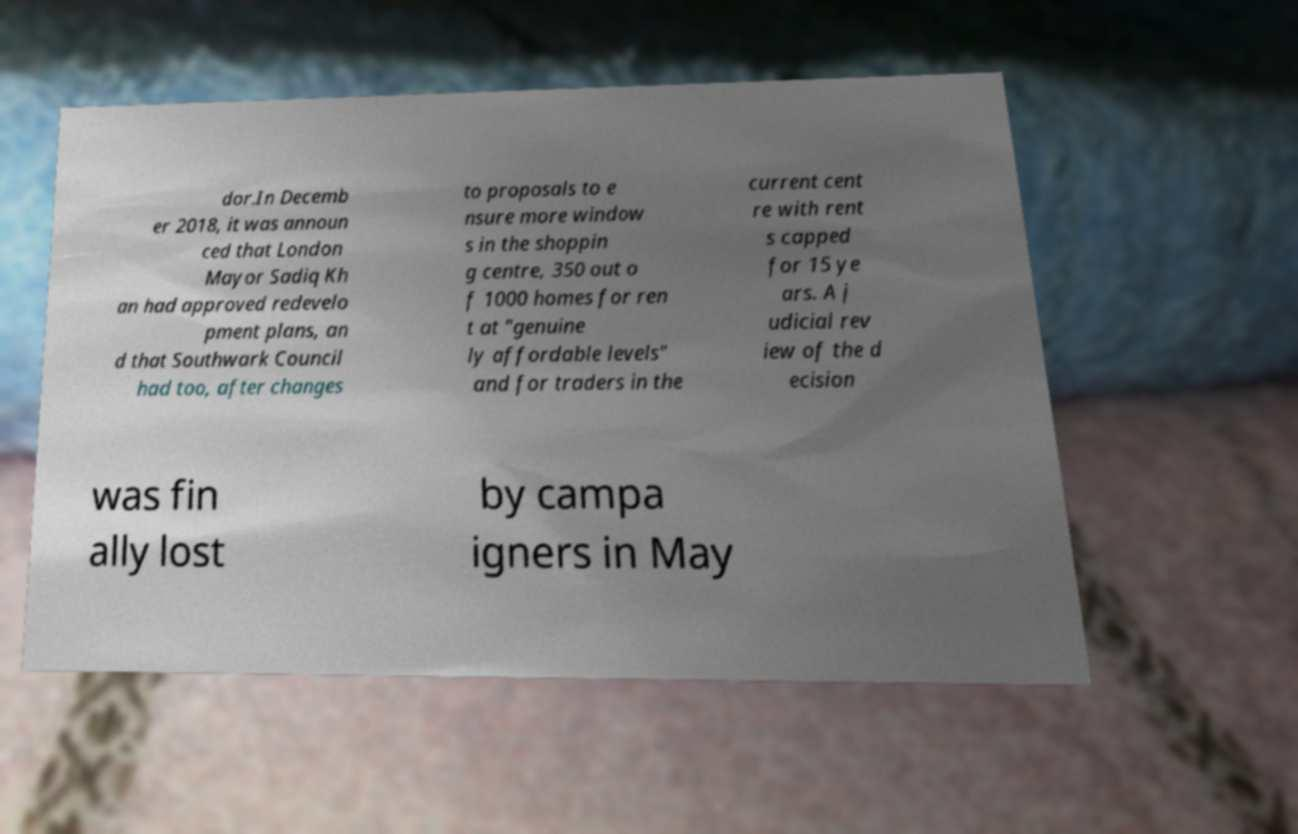Please read and relay the text visible in this image. What does it say? dor.In Decemb er 2018, it was announ ced that London Mayor Sadiq Kh an had approved redevelo pment plans, an d that Southwark Council had too, after changes to proposals to e nsure more window s in the shoppin g centre, 350 out o f 1000 homes for ren t at "genuine ly affordable levels" and for traders in the current cent re with rent s capped for 15 ye ars. A j udicial rev iew of the d ecision was fin ally lost by campa igners in May 